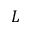<formula> <loc_0><loc_0><loc_500><loc_500>L</formula> 